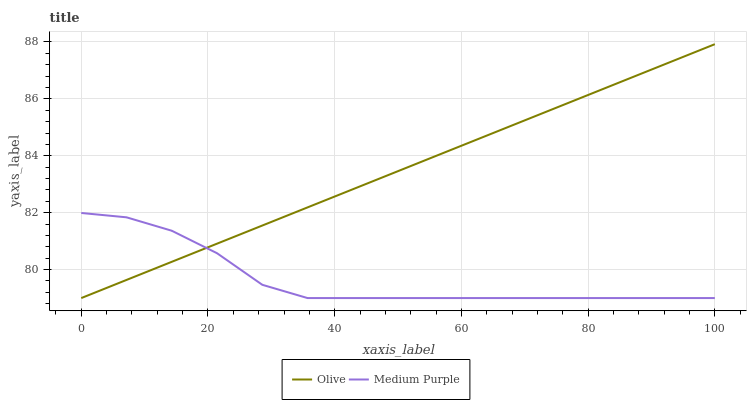Does Medium Purple have the minimum area under the curve?
Answer yes or no. Yes. Does Olive have the maximum area under the curve?
Answer yes or no. Yes. Does Medium Purple have the maximum area under the curve?
Answer yes or no. No. Is Olive the smoothest?
Answer yes or no. Yes. Is Medium Purple the roughest?
Answer yes or no. Yes. Is Medium Purple the smoothest?
Answer yes or no. No. Does Olive have the highest value?
Answer yes or no. Yes. Does Medium Purple have the highest value?
Answer yes or no. No. Does Olive intersect Medium Purple?
Answer yes or no. Yes. Is Olive less than Medium Purple?
Answer yes or no. No. Is Olive greater than Medium Purple?
Answer yes or no. No. 